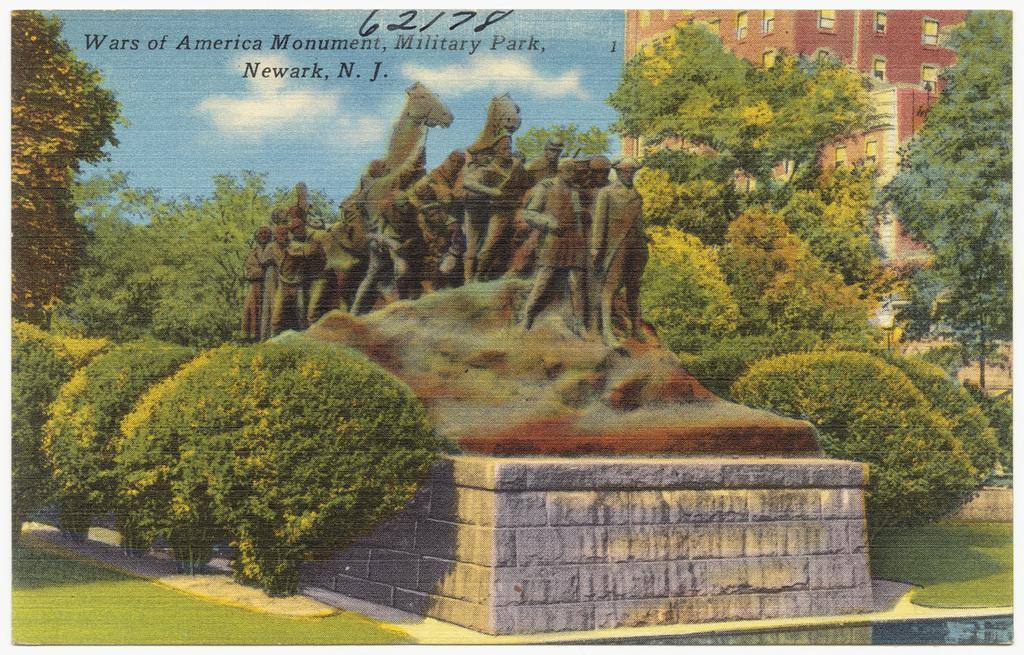In one or two sentences, can you explain what this image depicts? This image is a photograph. In the center of the image there is a statue. At the bottom we can see a pedestal. In the background there are trees, bushes, building and sky and we can see text. 